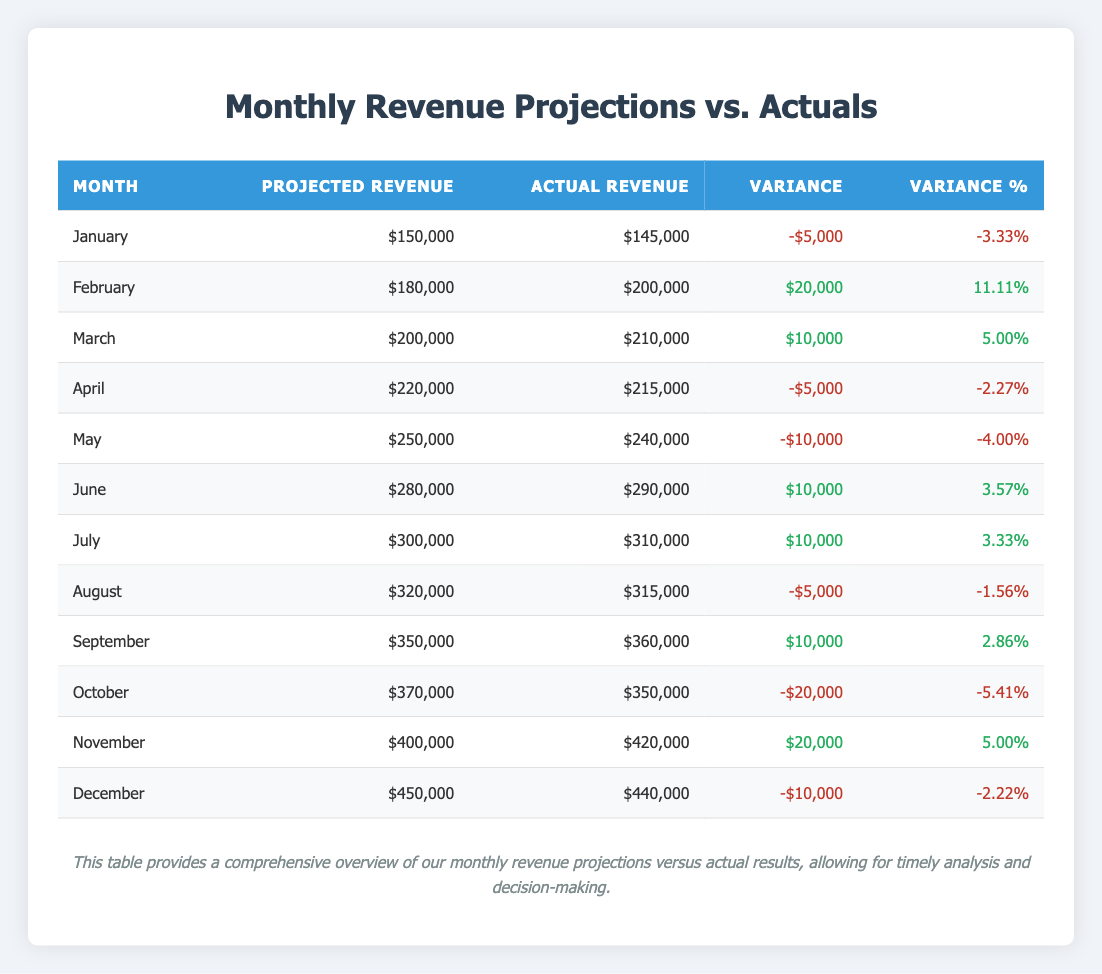What's the total projected revenue for the fiscal year? To find the total projected revenue, we sum the projected revenues for all months: $150,000 + $180,000 + $200,000 + $220,000 + $250,000 + $280,000 + $300,000 + $320,000 + $350,000 + $370,000 + $400,000 + $450,000 = $3,550,000.
Answer: $3,550,000 What was the actual revenue in March? The actual revenue for March is clearly stated in the table, which shows $210,000 as the figure for that month.
Answer: $210,000 Which month had the highest actual revenue? By examining the actual revenue figures, November has the highest actual revenue of $420,000.
Answer: November What is the variance for October? The variance for October is provided directly in the table as -$20,000, indicating that actual revenue was below the projected amount.
Answer: -$20,000 How many months had a positive variance in actual revenue? A positive variance is indicated by the values being greater than zero. Reviewing the table, the months with positive variances are February, March, June, July, September, and November, totaling 6 months.
Answer: 6 What percentage of the projected revenue for January was the actual revenue? To find this percentage, divide the actual revenue for January ($145,000) by the projected revenue ($150,000), then multiply by 100: ($145,000 / $150,000) * 100 = 96.67%.
Answer: 96.67% Which month had the largest negative variance? The table shows that October had the largest negative variance of -$20,000.
Answer: October What is the average variance for the entire fiscal year? To find the average variance, sum all variances: -5,000 + 20,000 + 10,000 - 5,000 - 10,000 + 10,000 + 10,000 - 5,000 + 10,000 - 20,000 + 20,000 - 10,000 = 0. Next, divide by the number of months (12): 0 / 12 = 0.
Answer: 0 Did any month exceed its projected revenue by more than 10%? A month exceeds its projected revenue by more than 10% if its variance percentage is greater than 10%. The only month that meets this criteria is February, which had a variance percentage of 11.11%.
Answer: Yes What is the total variance for the fiscal year? The total variance is found by summing all of the individual variances: -5,000 + 20,000 + 10,000 - 5,000 - 10,000 + 10,000 + 10,000 - 5,000 + 10,000 - 20,000 + 20,000 - 10,000, which equals 0.
Answer: 0 